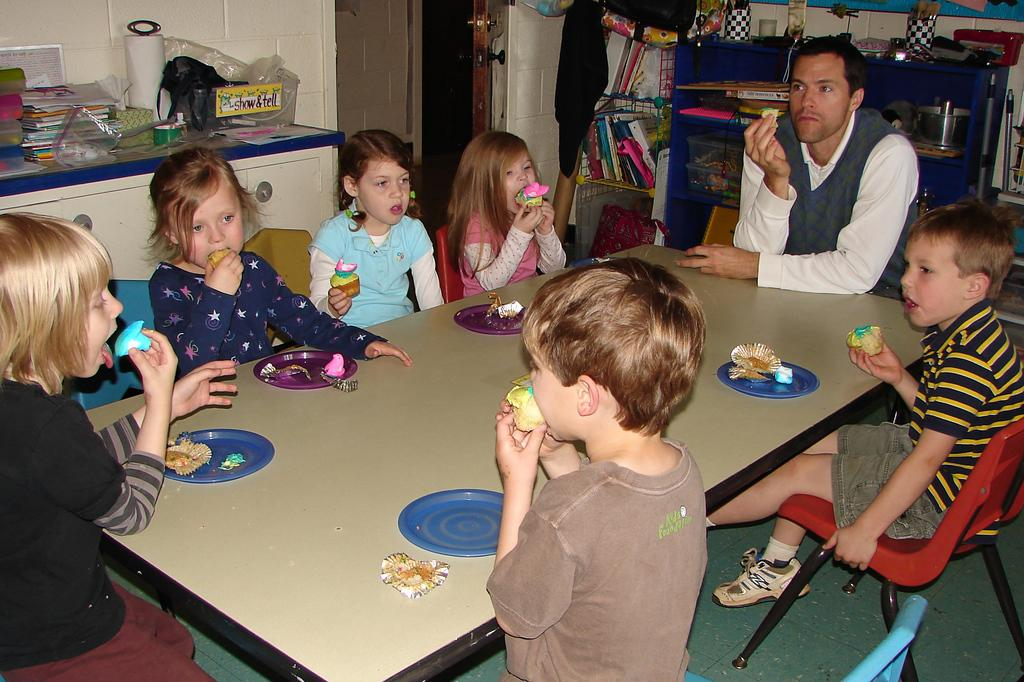What are the people in the image doing? There is a group of people sitting on chairs in the image. How are the chairs arranged in relation to each other? The chairs are arranged around a table. What can be found on the table? There are plates and food items on the table. What can be seen in the background of the image? In the background, there are books and tables. What type of record can be seen on the table in the image? There is no record present on the table in the image. What kind of flesh is visible on the plates in the image? There is no flesh visible on the plates in the image; only food items are present. 